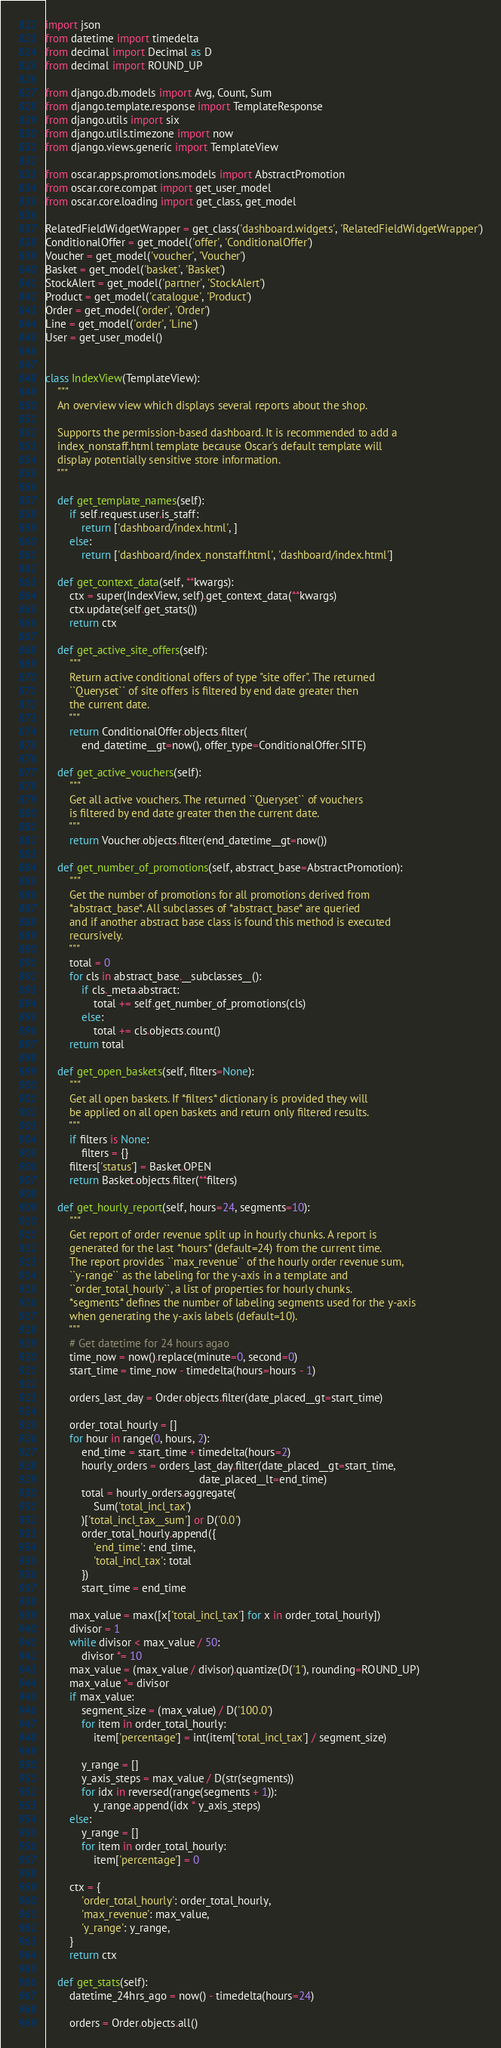<code> <loc_0><loc_0><loc_500><loc_500><_Python_>import json
from datetime import timedelta
from decimal import Decimal as D
from decimal import ROUND_UP

from django.db.models import Avg, Count, Sum
from django.template.response import TemplateResponse
from django.utils import six
from django.utils.timezone import now
from django.views.generic import TemplateView

from oscar.apps.promotions.models import AbstractPromotion
from oscar.core.compat import get_user_model
from oscar.core.loading import get_class, get_model

RelatedFieldWidgetWrapper = get_class('dashboard.widgets', 'RelatedFieldWidgetWrapper')
ConditionalOffer = get_model('offer', 'ConditionalOffer')
Voucher = get_model('voucher', 'Voucher')
Basket = get_model('basket', 'Basket')
StockAlert = get_model('partner', 'StockAlert')
Product = get_model('catalogue', 'Product')
Order = get_model('order', 'Order')
Line = get_model('order', 'Line')
User = get_user_model()


class IndexView(TemplateView):
    """
    An overview view which displays several reports about the shop.

    Supports the permission-based dashboard. It is recommended to add a
    index_nonstaff.html template because Oscar's default template will
    display potentially sensitive store information.
    """

    def get_template_names(self):
        if self.request.user.is_staff:
            return ['dashboard/index.html', ]
        else:
            return ['dashboard/index_nonstaff.html', 'dashboard/index.html']

    def get_context_data(self, **kwargs):
        ctx = super(IndexView, self).get_context_data(**kwargs)
        ctx.update(self.get_stats())
        return ctx

    def get_active_site_offers(self):
        """
        Return active conditional offers of type "site offer". The returned
        ``Queryset`` of site offers is filtered by end date greater then
        the current date.
        """
        return ConditionalOffer.objects.filter(
            end_datetime__gt=now(), offer_type=ConditionalOffer.SITE)

    def get_active_vouchers(self):
        """
        Get all active vouchers. The returned ``Queryset`` of vouchers
        is filtered by end date greater then the current date.
        """
        return Voucher.objects.filter(end_datetime__gt=now())

    def get_number_of_promotions(self, abstract_base=AbstractPromotion):
        """
        Get the number of promotions for all promotions derived from
        *abstract_base*. All subclasses of *abstract_base* are queried
        and if another abstract base class is found this method is executed
        recursively.
        """
        total = 0
        for cls in abstract_base.__subclasses__():
            if cls._meta.abstract:
                total += self.get_number_of_promotions(cls)
            else:
                total += cls.objects.count()
        return total

    def get_open_baskets(self, filters=None):
        """
        Get all open baskets. If *filters* dictionary is provided they will
        be applied on all open baskets and return only filtered results.
        """
        if filters is None:
            filters = {}
        filters['status'] = Basket.OPEN
        return Basket.objects.filter(**filters)

    def get_hourly_report(self, hours=24, segments=10):
        """
        Get report of order revenue split up in hourly chunks. A report is
        generated for the last *hours* (default=24) from the current time.
        The report provides ``max_revenue`` of the hourly order revenue sum,
        ``y-range`` as the labeling for the y-axis in a template and
        ``order_total_hourly``, a list of properties for hourly chunks.
        *segments* defines the number of labeling segments used for the y-axis
        when generating the y-axis labels (default=10).
        """
        # Get datetime for 24 hours agao
        time_now = now().replace(minute=0, second=0)
        start_time = time_now - timedelta(hours=hours - 1)

        orders_last_day = Order.objects.filter(date_placed__gt=start_time)

        order_total_hourly = []
        for hour in range(0, hours, 2):
            end_time = start_time + timedelta(hours=2)
            hourly_orders = orders_last_day.filter(date_placed__gt=start_time,
                                                   date_placed__lt=end_time)
            total = hourly_orders.aggregate(
                Sum('total_incl_tax')
            )['total_incl_tax__sum'] or D('0.0')
            order_total_hourly.append({
                'end_time': end_time,
                'total_incl_tax': total
            })
            start_time = end_time

        max_value = max([x['total_incl_tax'] for x in order_total_hourly])
        divisor = 1
        while divisor < max_value / 50:
            divisor *= 10
        max_value = (max_value / divisor).quantize(D('1'), rounding=ROUND_UP)
        max_value *= divisor
        if max_value:
            segment_size = (max_value) / D('100.0')
            for item in order_total_hourly:
                item['percentage'] = int(item['total_incl_tax'] / segment_size)

            y_range = []
            y_axis_steps = max_value / D(str(segments))
            for idx in reversed(range(segments + 1)):
                y_range.append(idx * y_axis_steps)
        else:
            y_range = []
            for item in order_total_hourly:
                item['percentage'] = 0

        ctx = {
            'order_total_hourly': order_total_hourly,
            'max_revenue': max_value,
            'y_range': y_range,
        }
        return ctx

    def get_stats(self):
        datetime_24hrs_ago = now() - timedelta(hours=24)

        orders = Order.objects.all()</code> 